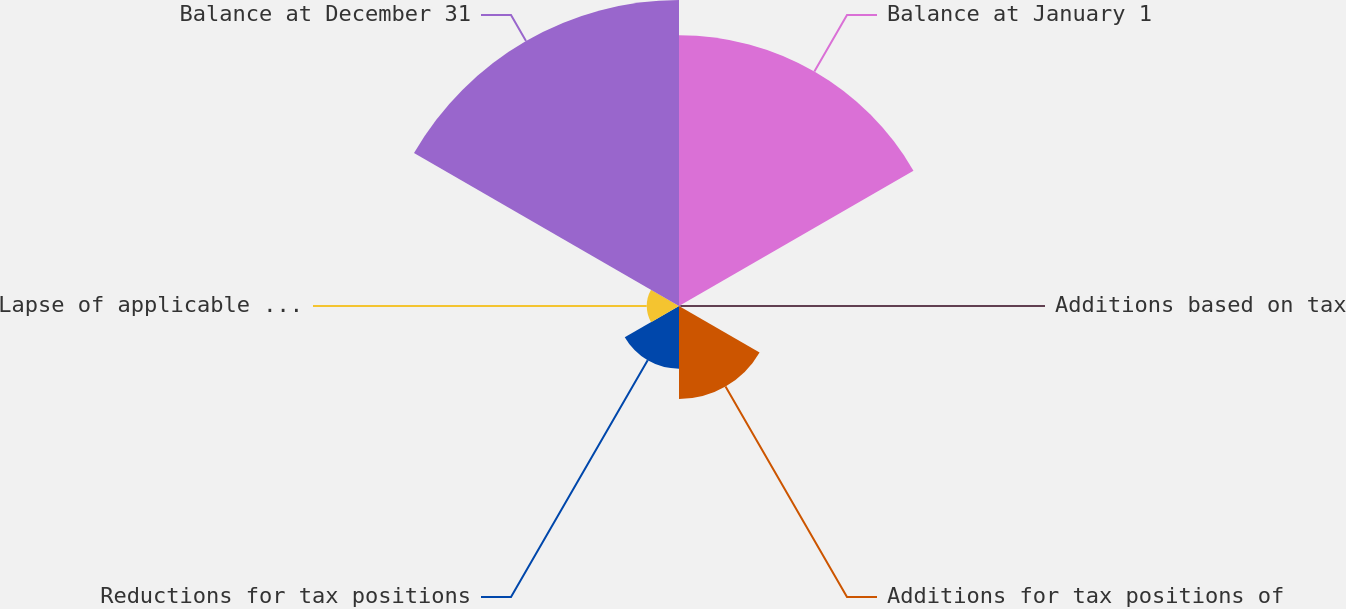Convert chart. <chart><loc_0><loc_0><loc_500><loc_500><pie_chart><fcel>Balance at January 1<fcel>Additions based on tax<fcel>Additions for tax positions of<fcel>Reductions for tax positions<fcel>Lapse of applicable statutes<fcel>Balance at December 31<nl><fcel>35.32%<fcel>0.24%<fcel>12.14%<fcel>8.17%<fcel>4.21%<fcel>39.92%<nl></chart> 